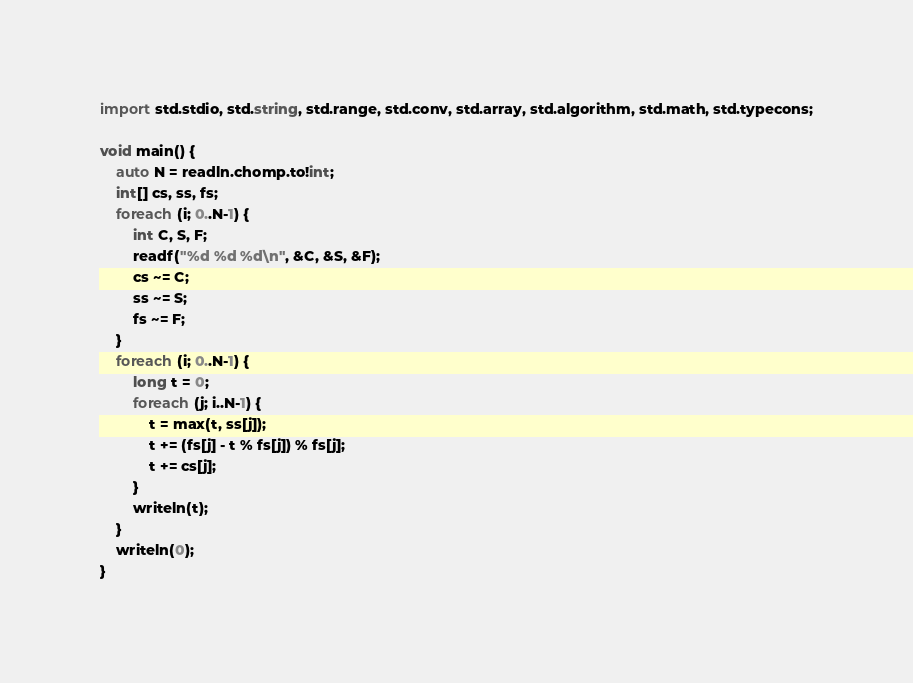<code> <loc_0><loc_0><loc_500><loc_500><_D_>import std.stdio, std.string, std.range, std.conv, std.array, std.algorithm, std.math, std.typecons;

void main() {
    auto N = readln.chomp.to!int;
    int[] cs, ss, fs;
    foreach (i; 0..N-1) {
        int C, S, F;
        readf("%d %d %d\n", &C, &S, &F);
        cs ~= C;
        ss ~= S;
        fs ~= F;
    }
    foreach (i; 0..N-1) {
        long t = 0;
        foreach (j; i..N-1) {
            t = max(t, ss[j]);
            t += (fs[j] - t % fs[j]) % fs[j];
            t += cs[j];
        }
        writeln(t);
    }
    writeln(0);
}

</code> 